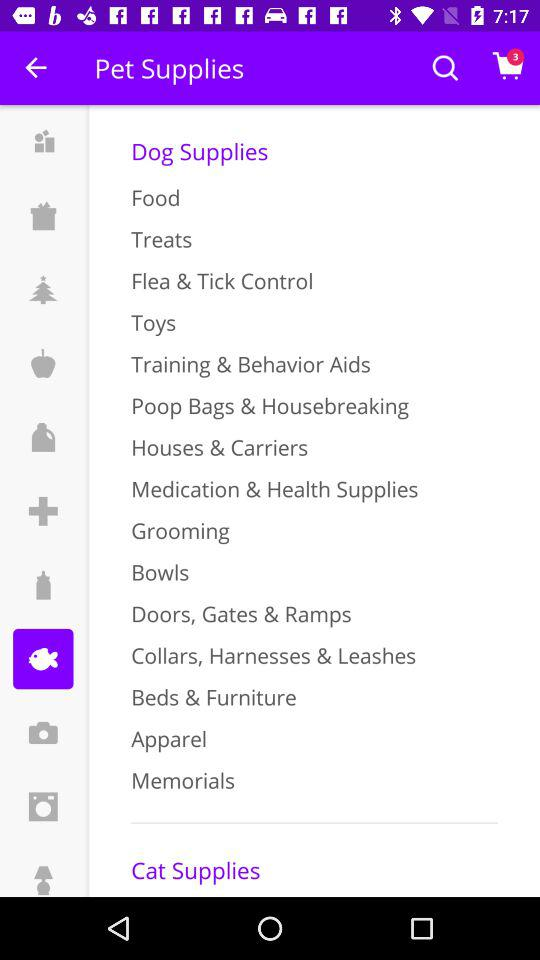How many items are there in the cart? There are 3 items in the cart. 